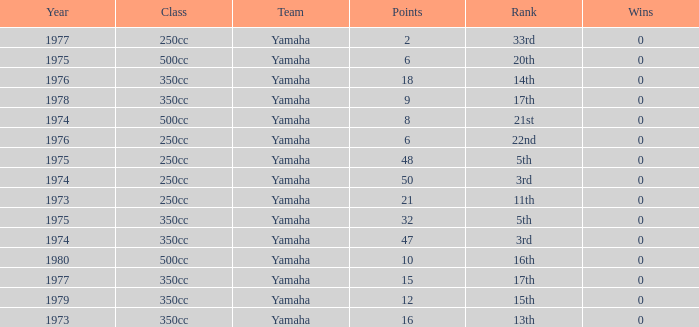Which Wins have a Class of 500cc, and a Year smaller than 1975? 0.0. 